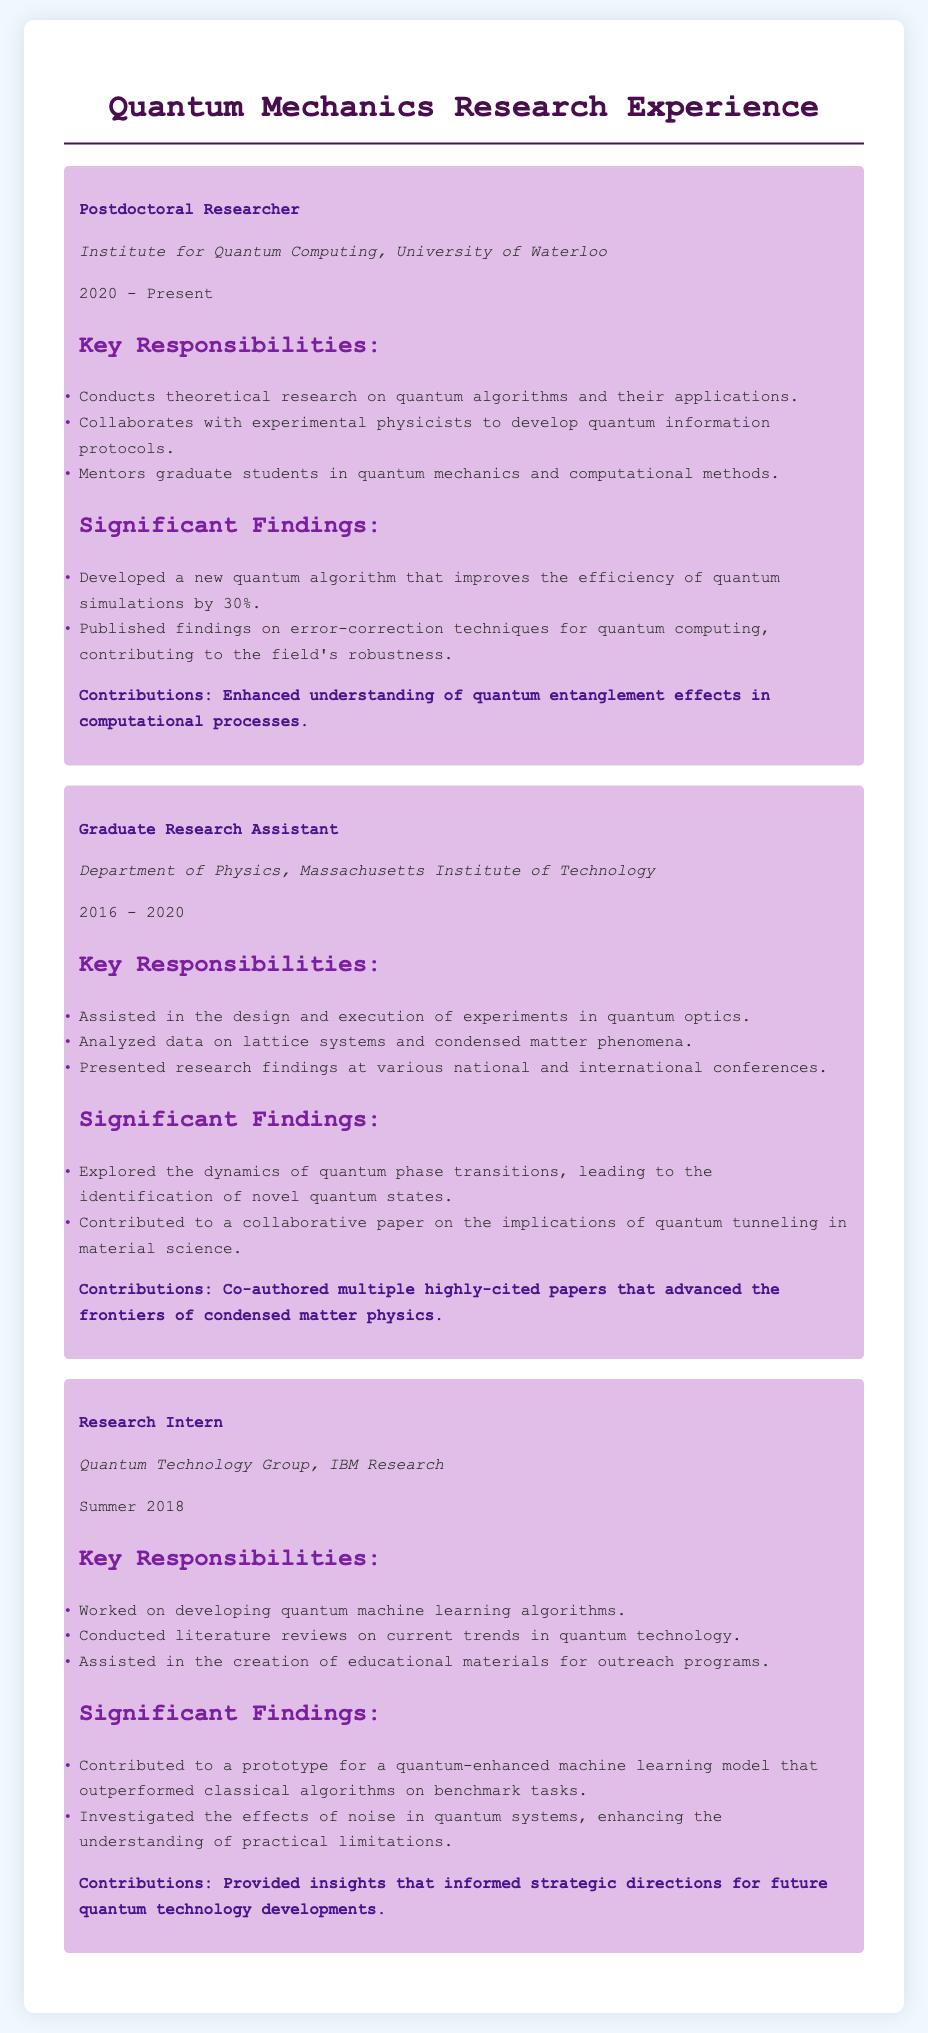what is the current position title held by the individual? The current position title is listed in the first section of the resume under "Postdoctoral Researcher".
Answer: Postdoctoral Researcher where is the individual currently working? The current workplace is specified in the institution section of the first position listed.
Answer: Institute for Quantum Computing, University of Waterloo how many years did the individual work as a Graduate Research Assistant? The duration of the Graduate Research Assistant position is indicated by the years listed in that section.
Answer: 4 years what is one of the significant findings during the Postdoctoral Researcher position? Significant findings are listed under the corresponding section for the Postdoctoral Researcher position.
Answer: Developed a new quantum algorithm that improves the efficiency of quantum simulations by 30% which institution did the individual intern at during the summer of 2018? The internship institution is mentioned in the Research Intern section of the document.
Answer: Quantum Technology Group, IBM Research what is the main contribution of the individual's work during their time as a Research Intern? Contributions are highlighted in each position's contributions section and summarize the impact of their work.
Answer: Provided insights that informed strategic directions for future quantum technology developments what type of research does the individual conduct as a Postdoctoral Researcher? The type of research is described in the key responsibilities section of the Postdoctoral Researcher position.
Answer: Theoretical research on quantum algorithms and their applications how many significant findings are mentioned for the Graduate Research Assistant position? The number of significant findings can be counted in the significant findings section of that position.
Answer: 2 significant findings 